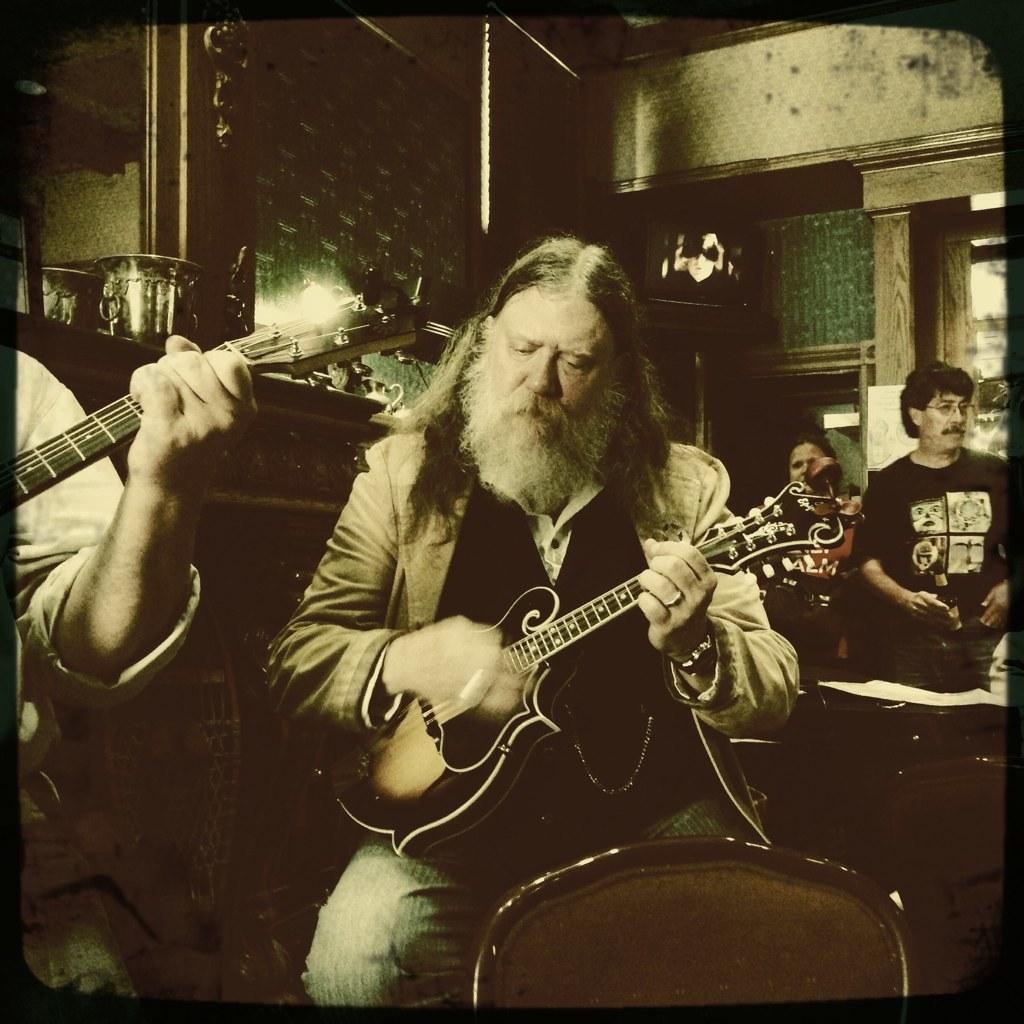Please provide a concise description of this image. In this image there is a man who is playing the violin with his hand. At the background there are people standing. At the top there is a wall. 